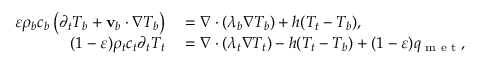<formula> <loc_0><loc_0><loc_500><loc_500>\begin{array} { r l } { \varepsilon \rho _ { b } c _ { b } \left ( \partial _ { t } T _ { b } + \mathbf v _ { b } \cdot \nabla T _ { b } \right ) } & = \nabla \cdot ( \lambda _ { b } \nabla T _ { b } ) + h ( T _ { t } - T _ { b } ) , } \\ { ( 1 - \varepsilon ) \rho _ { t } c _ { t } \partial _ { t } T _ { t } } & = \nabla \cdot ( \lambda _ { t } \nabla T _ { t } ) - h ( T _ { t } - T _ { b } ) + ( 1 - \varepsilon ) q _ { m e t } , } \end{array}</formula> 